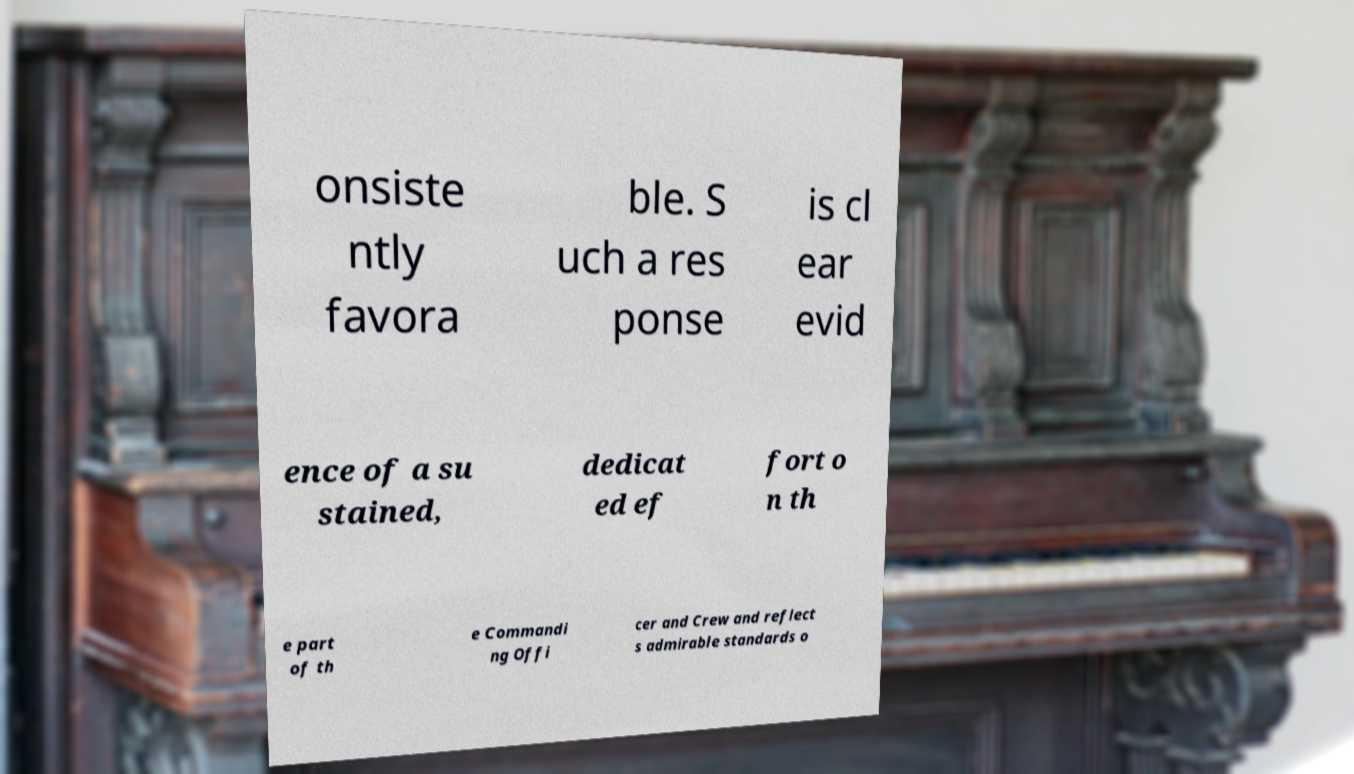There's text embedded in this image that I need extracted. Can you transcribe it verbatim? onsiste ntly favora ble. S uch a res ponse is cl ear evid ence of a su stained, dedicat ed ef fort o n th e part of th e Commandi ng Offi cer and Crew and reflect s admirable standards o 